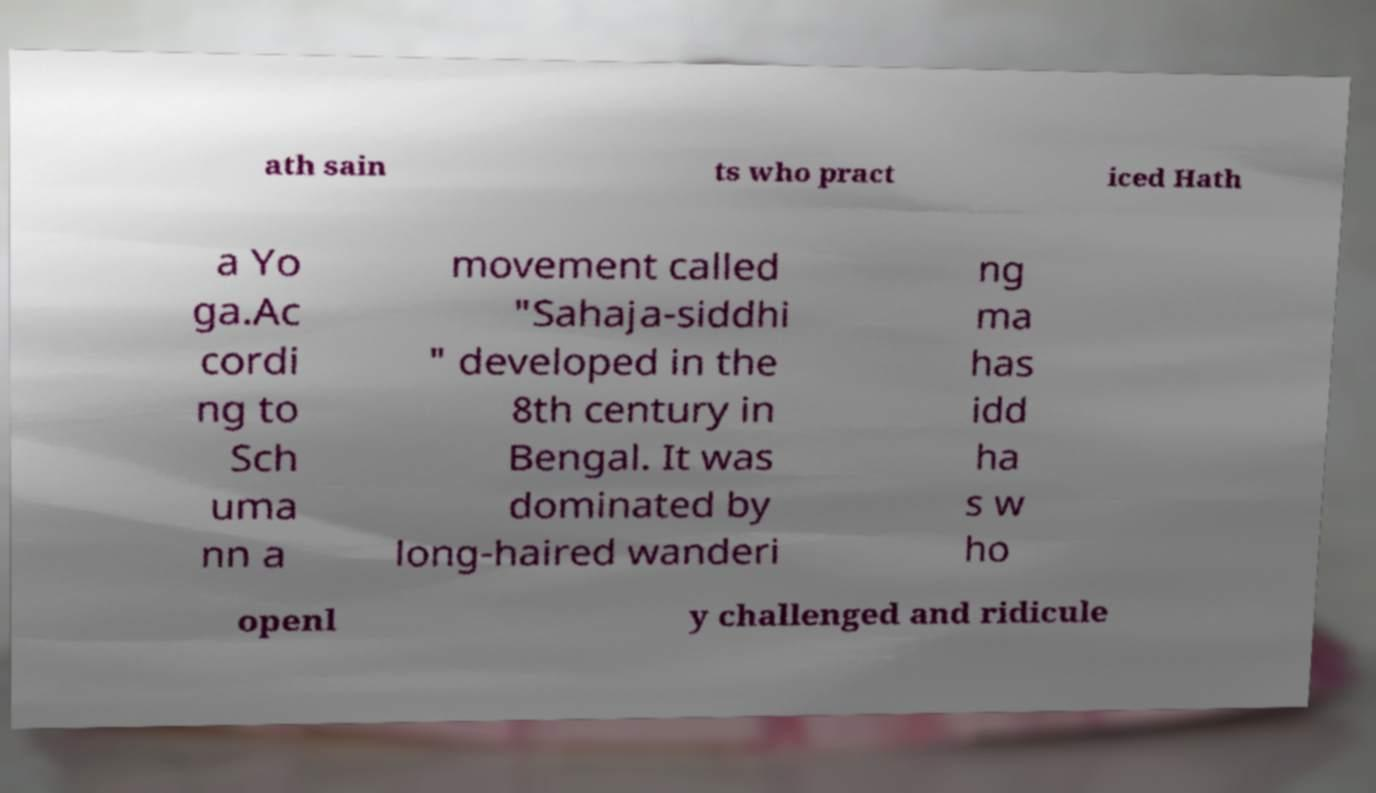There's text embedded in this image that I need extracted. Can you transcribe it verbatim? ath sain ts who pract iced Hath a Yo ga.Ac cordi ng to Sch uma nn a movement called "Sahaja-siddhi " developed in the 8th century in Bengal. It was dominated by long-haired wanderi ng ma has idd ha s w ho openl y challenged and ridicule 